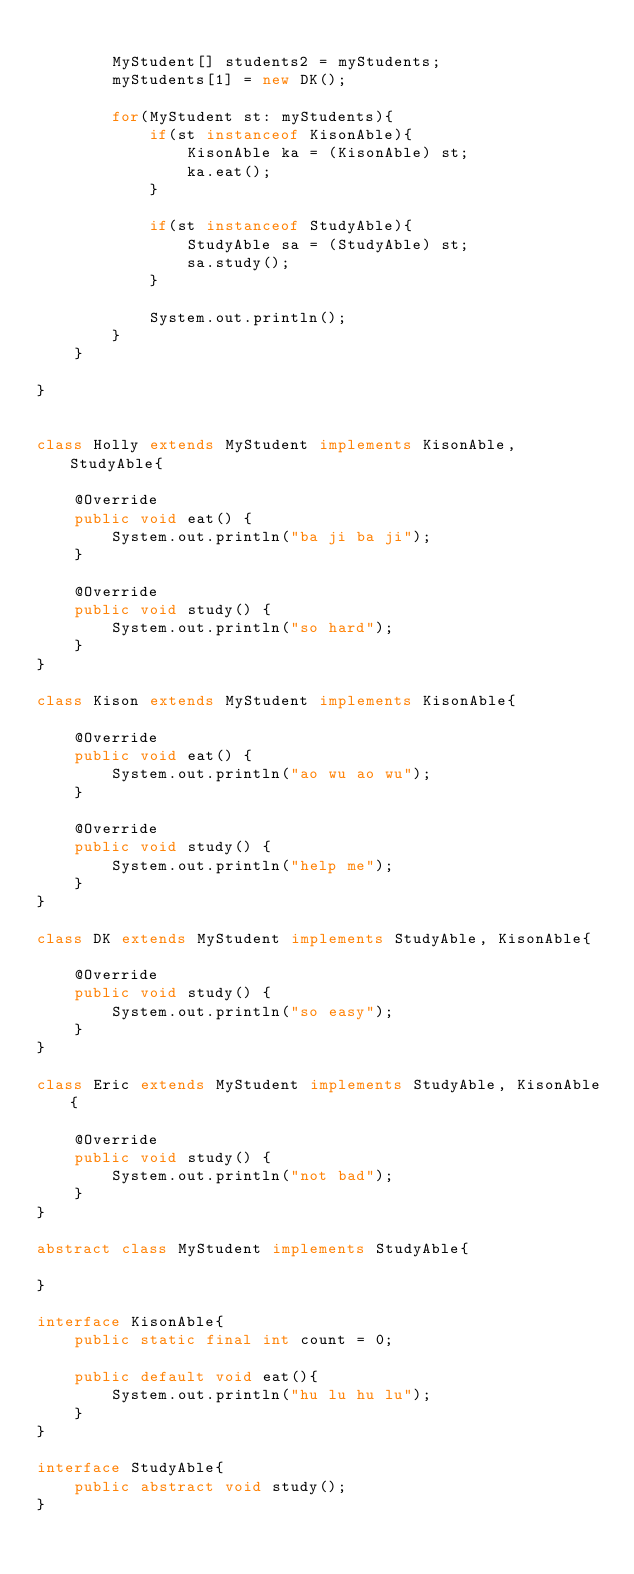Convert code to text. <code><loc_0><loc_0><loc_500><loc_500><_Java_>
        MyStudent[] students2 = myStudents;
        myStudents[1] = new DK();

        for(MyStudent st: myStudents){
            if(st instanceof KisonAble){
                KisonAble ka = (KisonAble) st;
                ka.eat();
            }

            if(st instanceof StudyAble){
                StudyAble sa = (StudyAble) st;
                sa.study();
            }

            System.out.println();
        }
    }

}


class Holly extends MyStudent implements KisonAble, StudyAble{

    @Override
    public void eat() {
        System.out.println("ba ji ba ji");
    }

    @Override
    public void study() {
        System.out.println("so hard");
    }
}

class Kison extends MyStudent implements KisonAble{

    @Override
    public void eat() {
        System.out.println("ao wu ao wu");
    }

    @Override
    public void study() {
        System.out.println("help me");
    }
}

class DK extends MyStudent implements StudyAble, KisonAble{

    @Override
    public void study() {
        System.out.println("so easy");
    }
}

class Eric extends MyStudent implements StudyAble, KisonAble{

    @Override
    public void study() {
        System.out.println("not bad");
    }
}

abstract class MyStudent implements StudyAble{

}

interface KisonAble{
    public static final int count = 0;

    public default void eat(){
        System.out.println("hu lu hu lu");
    }
}

interface StudyAble{
    public abstract void study();
}</code> 